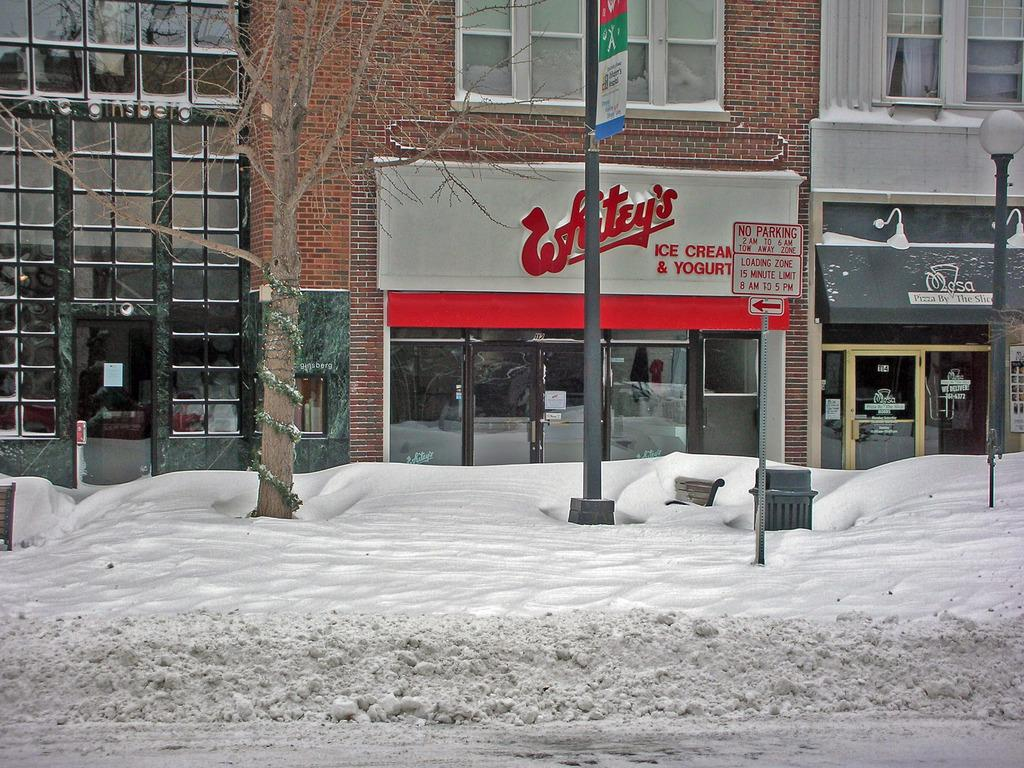What is the main feature of the image? There is a road in the image. What is the weather condition in the image? There is snow in the image. Are there any seating arrangements in the image? Yes, there is a bench in the image. What is used for waste disposal in the image? There is a bin in the image. What type of vegetation is present in the image? There is a tree in the image. What are the vertical structures in the image? There are poles and a light pole in the image. What is used for identification in the image? There are name boards in the image. What is used for illumination in the image? There is a lamp in the image. What type of window treatment is present in the image? There are curtains in the image. What type of entryways are present in the image? There are doors in the image. What type of structures are present with windows in the image? There are buildings with windows in the image. What are the unspecified objects in the image? The unspecified objects in the image are not mentioned in the provided facts. What type of nail is used to hang the lunchroom sign in the image? There is no lunchroom or sign present in the image, so it is not possible to determine what type of nail might be used. 